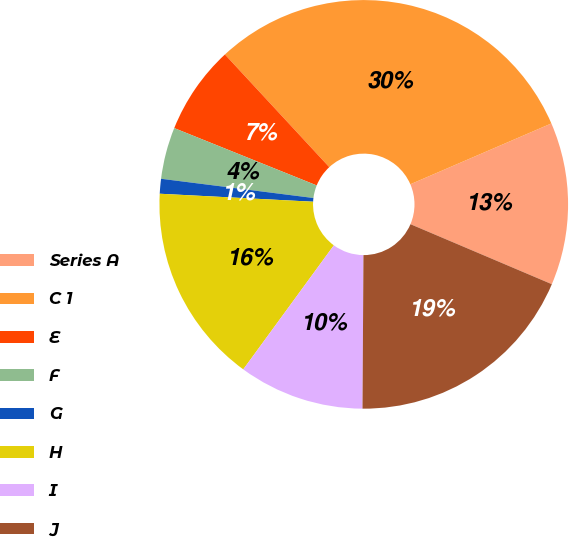Convert chart to OTSL. <chart><loc_0><loc_0><loc_500><loc_500><pie_chart><fcel>Series A<fcel>C 1<fcel>E<fcel>F<fcel>G<fcel>H<fcel>I<fcel>J<nl><fcel>12.87%<fcel>30.41%<fcel>7.02%<fcel>4.09%<fcel>1.17%<fcel>15.79%<fcel>9.94%<fcel>18.71%<nl></chart> 